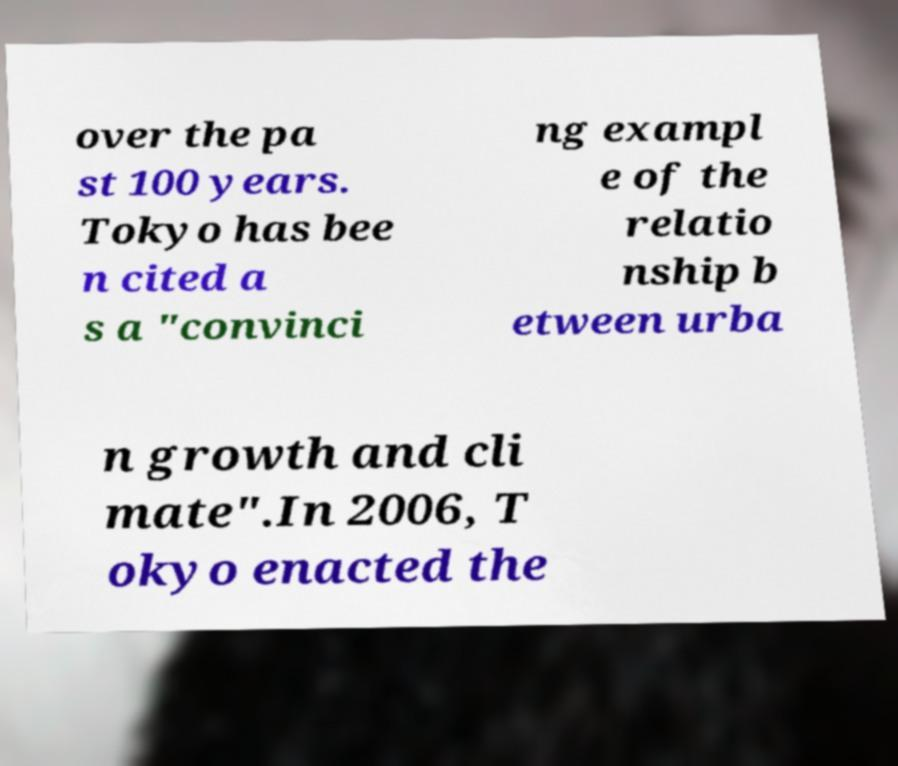Could you extract and type out the text from this image? over the pa st 100 years. Tokyo has bee n cited a s a "convinci ng exampl e of the relatio nship b etween urba n growth and cli mate".In 2006, T okyo enacted the 